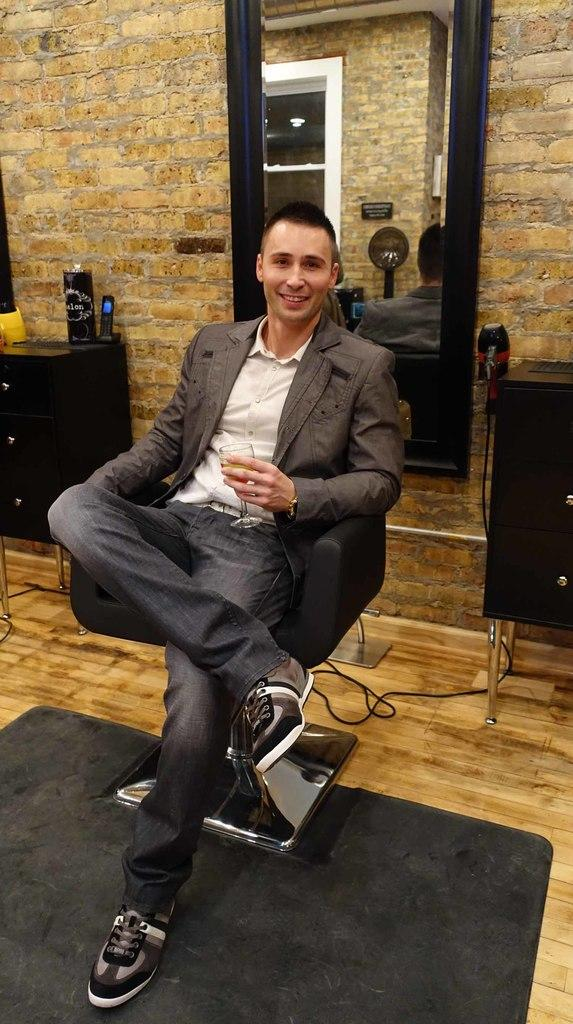Who is present in the image? There is a man in the image. What is the man doing in the image? The man is sitting on a chair in the image. What object can be seen in the background of the image? There is a mirror in the image. Can you describe the setting of the image? The setting appears to be inside a barber shop. What type of wing can be seen on the man in the image? There is no wing visible on the man in the image. Can you tell me how many jars of hair gel are on the shelf behind the man? The image does not provide information about the number of jars of hair gel on the shelf behind the man. 